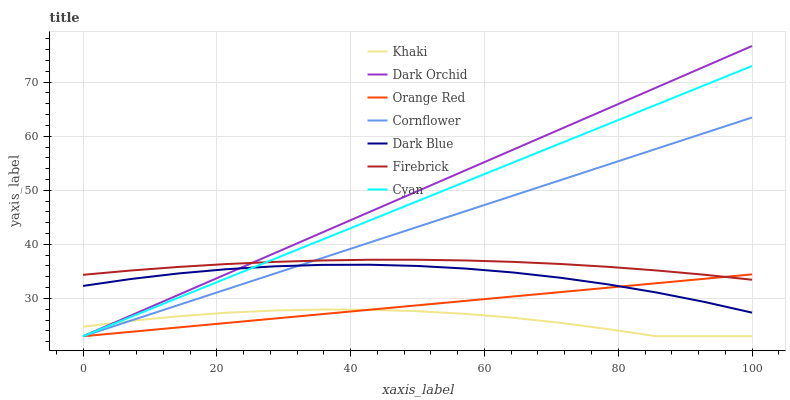Does Khaki have the minimum area under the curve?
Answer yes or no. Yes. Does Dark Orchid have the maximum area under the curve?
Answer yes or no. Yes. Does Firebrick have the minimum area under the curve?
Answer yes or no. No. Does Firebrick have the maximum area under the curve?
Answer yes or no. No. Is Orange Red the smoothest?
Answer yes or no. Yes. Is Khaki the roughest?
Answer yes or no. Yes. Is Firebrick the smoothest?
Answer yes or no. No. Is Firebrick the roughest?
Answer yes or no. No. Does Firebrick have the lowest value?
Answer yes or no. No. Does Dark Orchid have the highest value?
Answer yes or no. Yes. Does Firebrick have the highest value?
Answer yes or no. No. Is Dark Blue less than Firebrick?
Answer yes or no. Yes. Is Firebrick greater than Khaki?
Answer yes or no. Yes. Does Cornflower intersect Orange Red?
Answer yes or no. Yes. Is Cornflower less than Orange Red?
Answer yes or no. No. Is Cornflower greater than Orange Red?
Answer yes or no. No. Does Dark Blue intersect Firebrick?
Answer yes or no. No. 